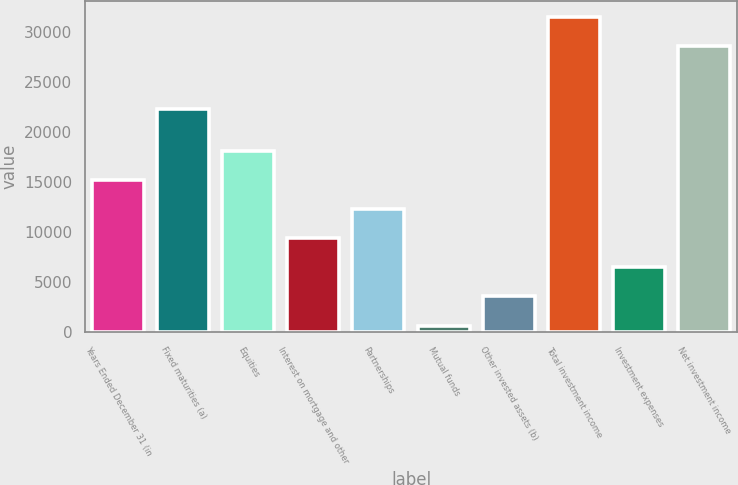<chart> <loc_0><loc_0><loc_500><loc_500><bar_chart><fcel>Years Ended December 31 (in<fcel>Fixed maturities (a)<fcel>Equities<fcel>Interest on mortgage and other<fcel>Partnerships<fcel>Mutual funds<fcel>Other invested assets (b)<fcel>Total investment income<fcel>Investment expenses<fcel>Net investment income<nl><fcel>15170.5<fcel>22330<fcel>18074.6<fcel>9362.3<fcel>12266.4<fcel>650<fcel>3554.1<fcel>31523.1<fcel>6458.2<fcel>28619<nl></chart> 